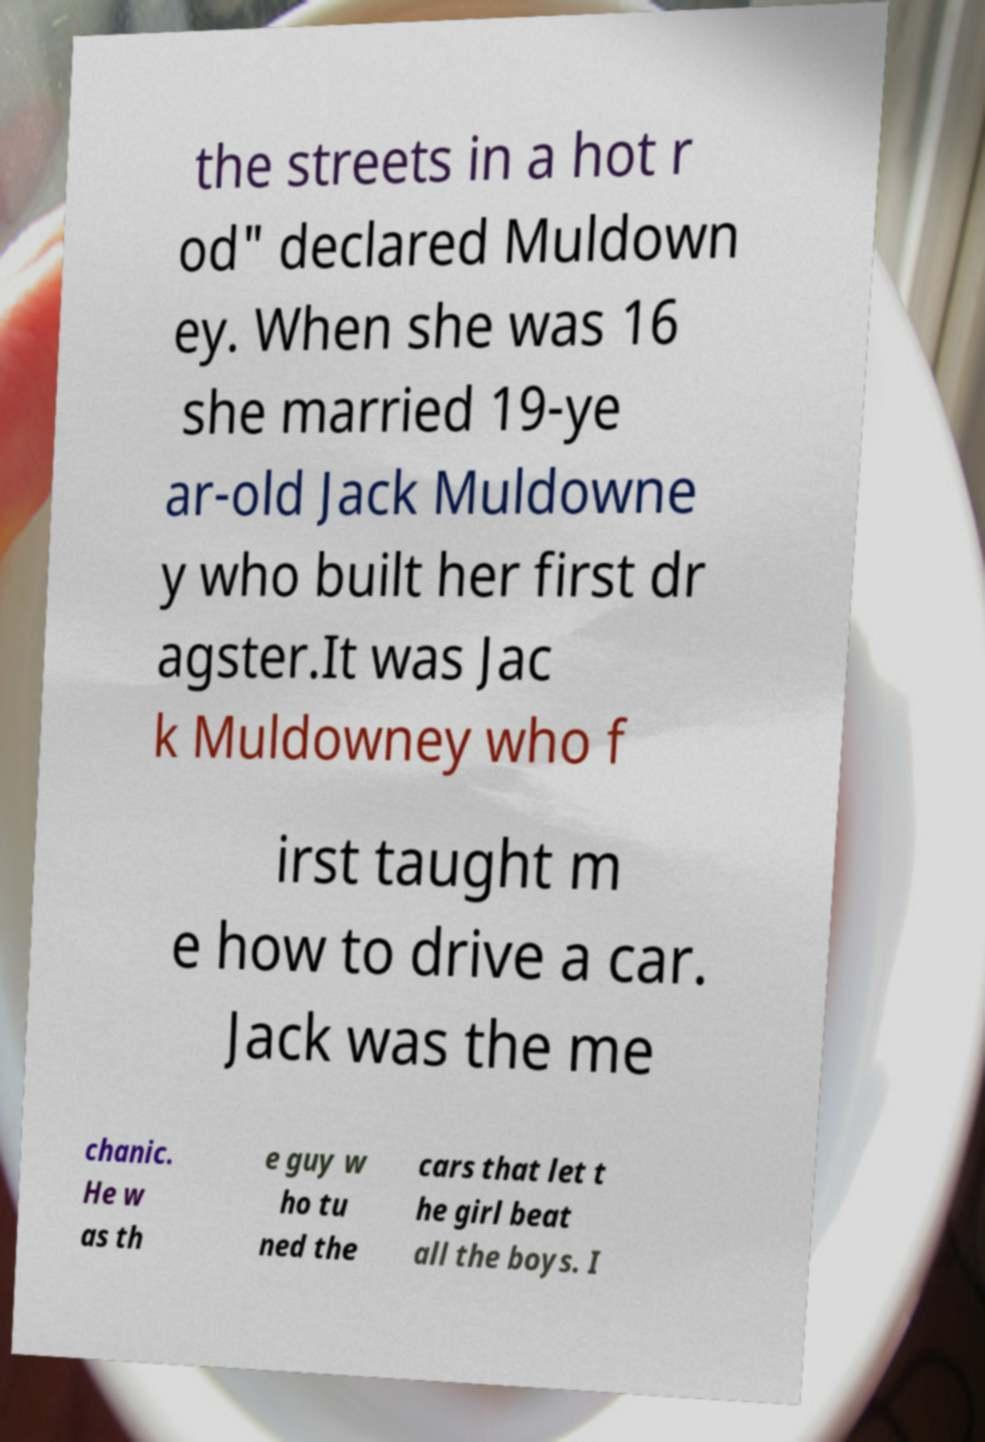Please identify and transcribe the text found in this image. the streets in a hot r od" declared Muldown ey. When she was 16 she married 19-ye ar-old Jack Muldowne y who built her first dr agster.It was Jac k Muldowney who f irst taught m e how to drive a car. Jack was the me chanic. He w as th e guy w ho tu ned the cars that let t he girl beat all the boys. I 